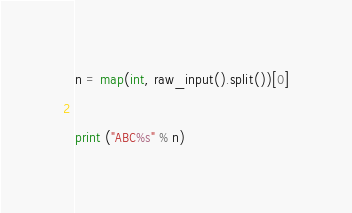<code> <loc_0><loc_0><loc_500><loc_500><_Python_>n = map(int, raw_input().split())[0]

print ("ABC%s" % n)</code> 